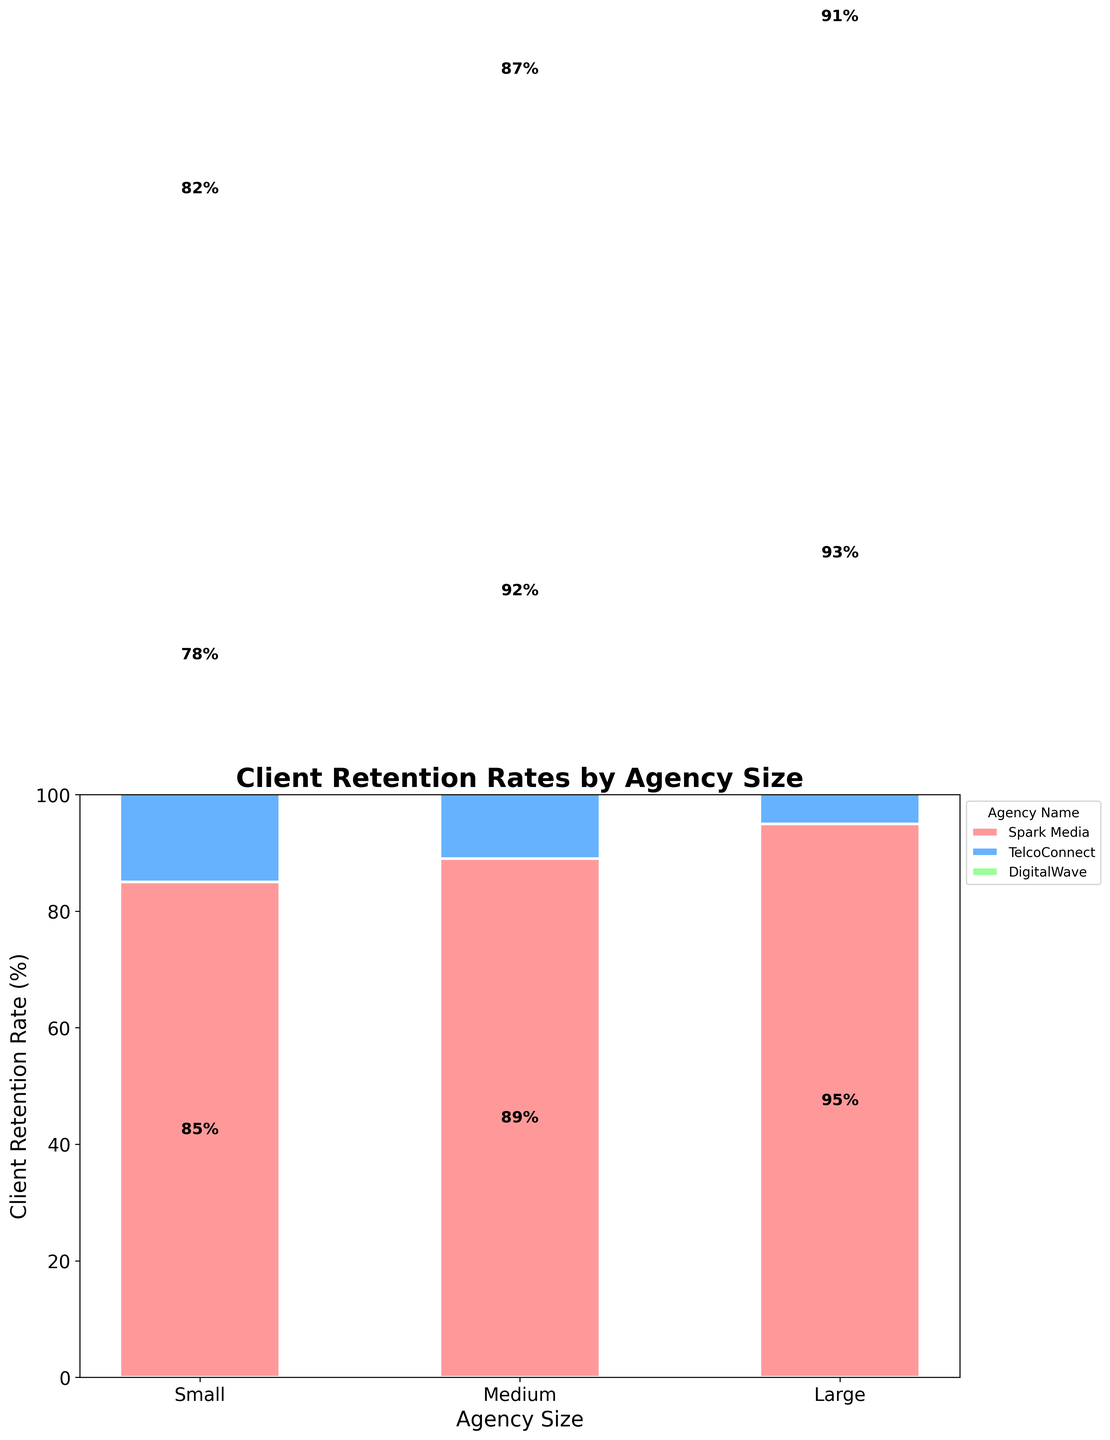What is the title of the plot? The title of the plot is often found at the top and summarizes what the visual represents. In this case, the title 'Client Retention Rates by Agency Size' is centered at the top in larger, bolder font.
Answer: Client Retention Rates by Agency Size Which agency size category has the highest client retention rate? By examining the top bar segments within each agency size, the 'Large' category consistently has higher segments, with the top retention rates shown for GroupM, Omnicom Media Group, and Publicis Media.
Answer: Large What is the retention rate for Spark Media? Spark Media is among the 'Small' agencies and is represented by the first segment in the 'Small' category. The label inside the segment indicates an 85% retention rate.
Answer: 85% Compare the highest client retention rate in the 'Small' category to that in the 'Large' category. The highest retention rate in the 'Small' category is 85% for Spark Media. In the 'Large' category, the highest retention rate is 95% for GroupM. Comparing these, 95% is higher than 85%.
Answer: Large category is higher Which agency from the 'Medium' size has the highest client retention rate, and what is the value? In the 'Medium' category, by analyzing the retention rates labeled in each segment, Mindshare has the highest retention rate, noted with 92%.
Answer: Mindshare, 92% What is the total client retention rate percentage for all small agencies combined? Summing the individual retention rates of the 'Small' agencies: Spark Media (85%), TelcoConnect (78%), and DigitalWave (82%) yields a total of 85 + 78 + 82 = 245%.
Answer: 245% How does the client retention rate of MediaCom compare to that of Zenith? MediaCom's retention rate in the 'Medium' category is 89%, while Zenith's is 87%, so MediaCom has a higher client retention rate by 2%.
Answer: MediaCom is higher by 2% What colors are used to represent the different agency names in the plot? The plot uses three colors to represent different agency names: light red, light blue, and light green, which differentiate the agencies within each size category.
Answer: Light red, light blue, light green What is the average client retention rate for 'Large' agencies? The retention rates for the 'Large' agencies are 95% (GroupM), 93% (Omnicom Media Group), and 91% (Publicis Media). The average is calculated as (95 + 93 + 91) / 3 = 279 / 3 = 93%.
Answer: 93% How does the sum of retention rates for 'Medium' agencies compare to the sum for 'Large' agencies? Summing the 'Medium' agency rates: MediaCom (89%), Mindshare (92%), Zenith (87%) gives 89 + 92 + 87 = 268%. For 'Large' agencies: GroupM (95%), Omnicom Media Group (93%), Publicis Media (91%), summing up results in 95 + 93 + 91 = 279%. Comparing these sums, 279% is higher than 268%.
Answer: Large agencies have a higher sum 